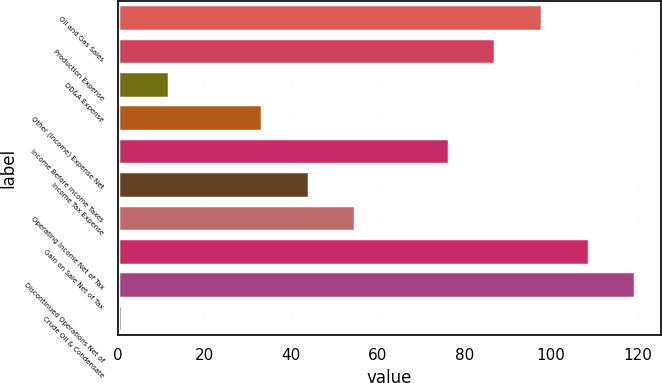Convert chart to OTSL. <chart><loc_0><loc_0><loc_500><loc_500><bar_chart><fcel>Oil and Gas Sales<fcel>Production Expense<fcel>DD&A Expense<fcel>Other (Income) Expense Net<fcel>Income Before Income Taxes<fcel>Income Tax Expense<fcel>Operating Income Net of Tax<fcel>Gain on Sale Net of Tax<fcel>Discontinued Operations Net of<fcel>Crude Oil & Condensate<nl><fcel>97.93<fcel>87.16<fcel>11.77<fcel>33.31<fcel>76.39<fcel>44.08<fcel>54.85<fcel>108.7<fcel>119.47<fcel>1<nl></chart> 